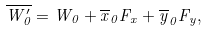Convert formula to latex. <formula><loc_0><loc_0><loc_500><loc_500>\overline { W _ { 0 } ^ { \prime } } = W _ { 0 } + \overline { x } _ { 0 } F _ { x } + \overline { y } _ { 0 } F _ { y } ,</formula> 